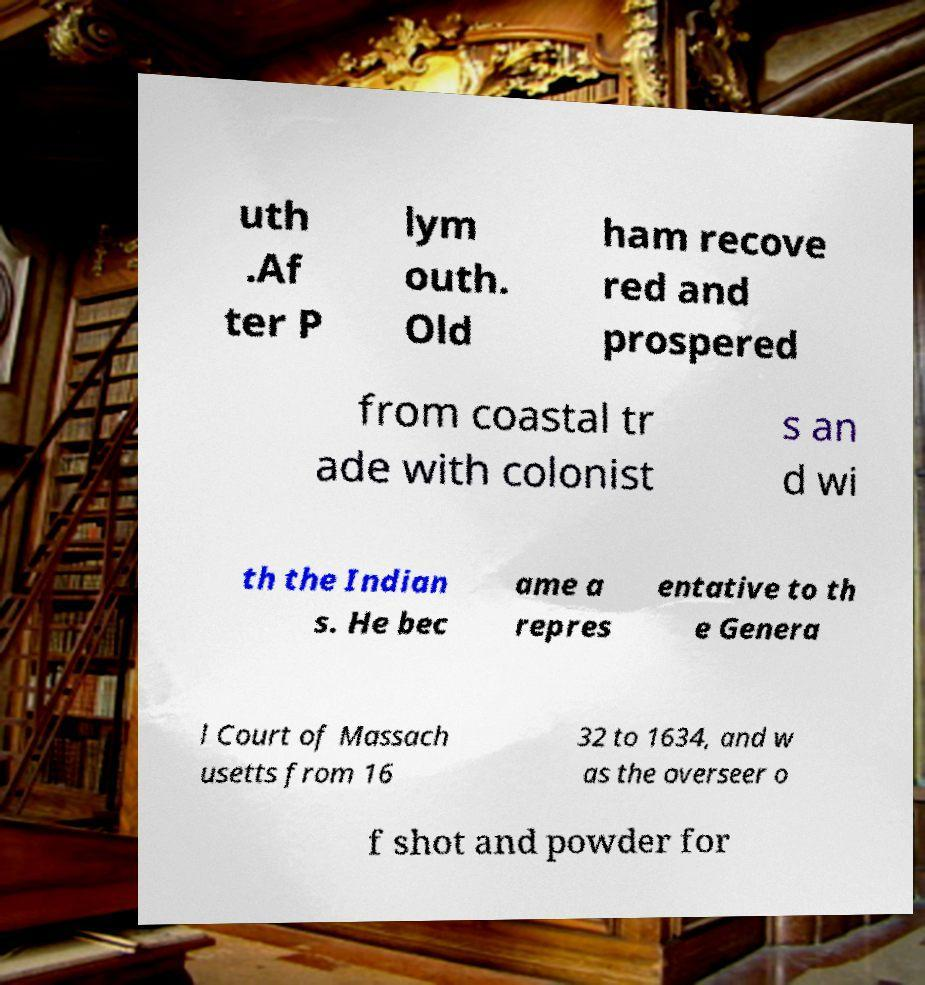What messages or text are displayed in this image? I need them in a readable, typed format. uth .Af ter P lym outh. Old ham recove red and prospered from coastal tr ade with colonist s an d wi th the Indian s. He bec ame a repres entative to th e Genera l Court of Massach usetts from 16 32 to 1634, and w as the overseer o f shot and powder for 